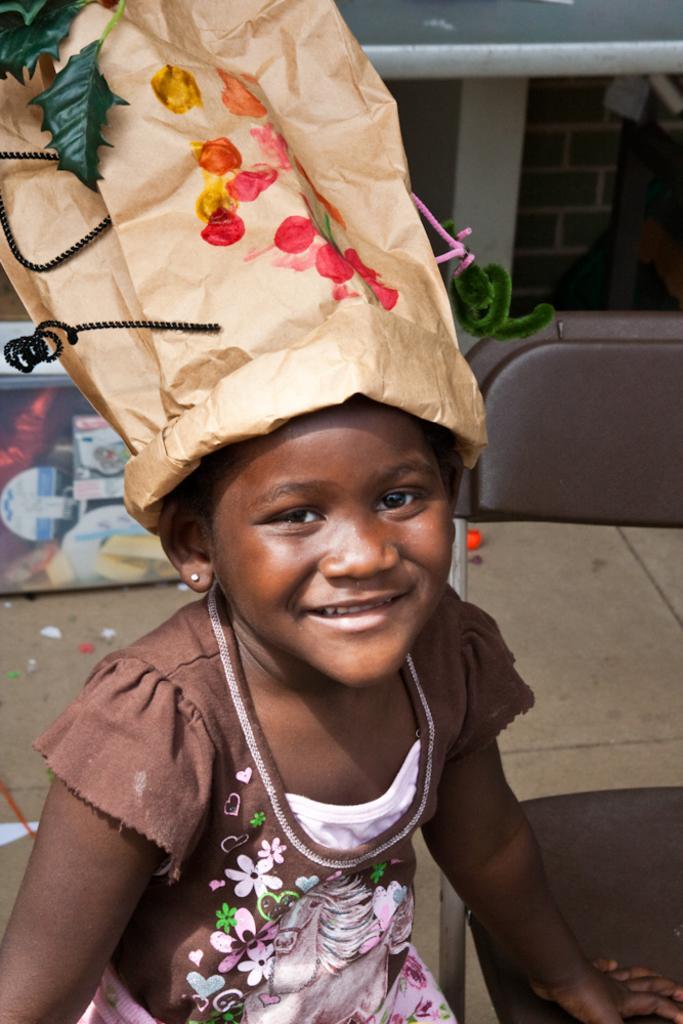In one or two sentences, can you explain what this image depicts? In this picture, there is a kid and she is wearing a brown frock. On her head, there is a paper bag with colors. Beside her, there is a chair. 